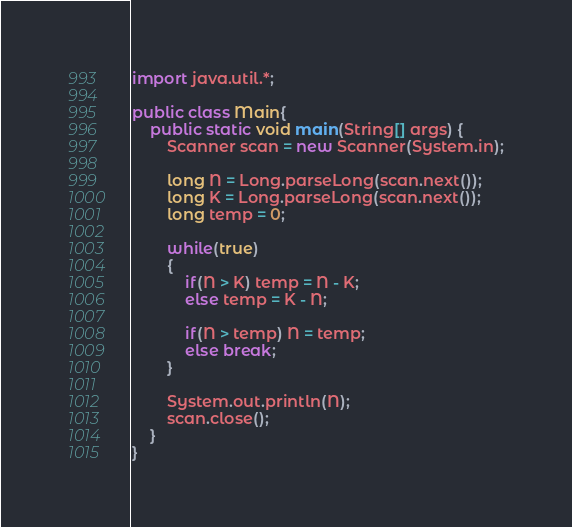<code> <loc_0><loc_0><loc_500><loc_500><_Java_>import java.util.*;

public class Main{
    public static void main(String[] args) {
        Scanner scan = new Scanner(System.in);

        long N = Long.parseLong(scan.next());
        long K = Long.parseLong(scan.next());
        long temp = 0;
        
        while(true)
        {
            if(N > K) temp = N - K;
            else temp = K - N;
            
            if(N > temp) N = temp;
            else break;
        }

        System.out.println(N);
        scan.close();
    }
}</code> 